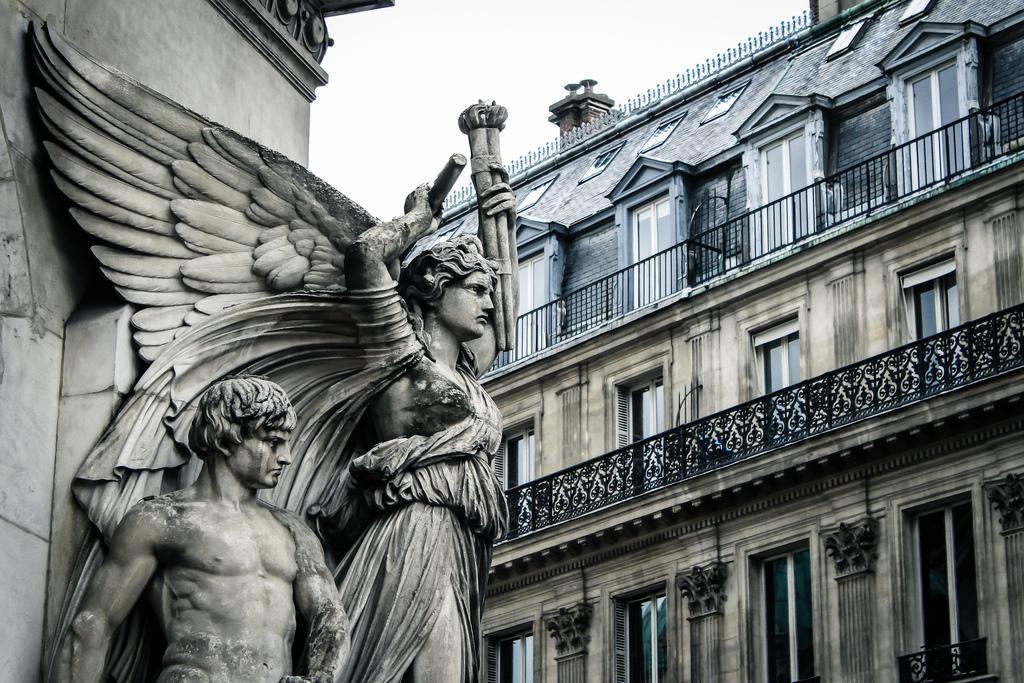How would you summarize this image in a sentence or two? This image is taken outdoors. At the top of the image there is the sky. In the background there are two buildings with walls, windows, doors, balconies, railings and roofs. There are a few carvings on the walls. In the middle of the image there are two sculptures of a man and a woman. 